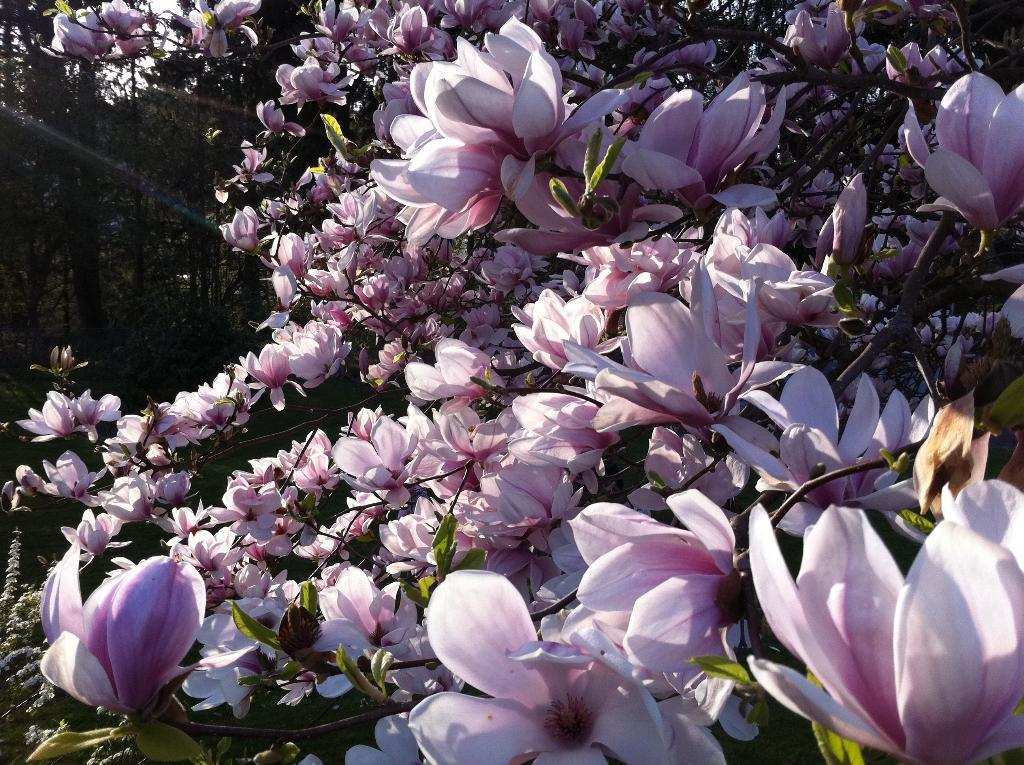Describe this image in one or two sentences. Here in this picture we can see number of flowers present on plants and we can also see other plants and trees present over there. 